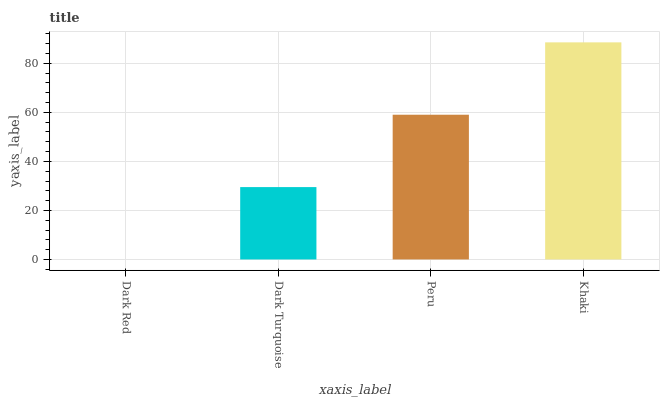Is Dark Turquoise the minimum?
Answer yes or no. No. Is Dark Turquoise the maximum?
Answer yes or no. No. Is Dark Turquoise greater than Dark Red?
Answer yes or no. Yes. Is Dark Red less than Dark Turquoise?
Answer yes or no. Yes. Is Dark Red greater than Dark Turquoise?
Answer yes or no. No. Is Dark Turquoise less than Dark Red?
Answer yes or no. No. Is Peru the high median?
Answer yes or no. Yes. Is Dark Turquoise the low median?
Answer yes or no. Yes. Is Dark Turquoise the high median?
Answer yes or no. No. Is Dark Red the low median?
Answer yes or no. No. 